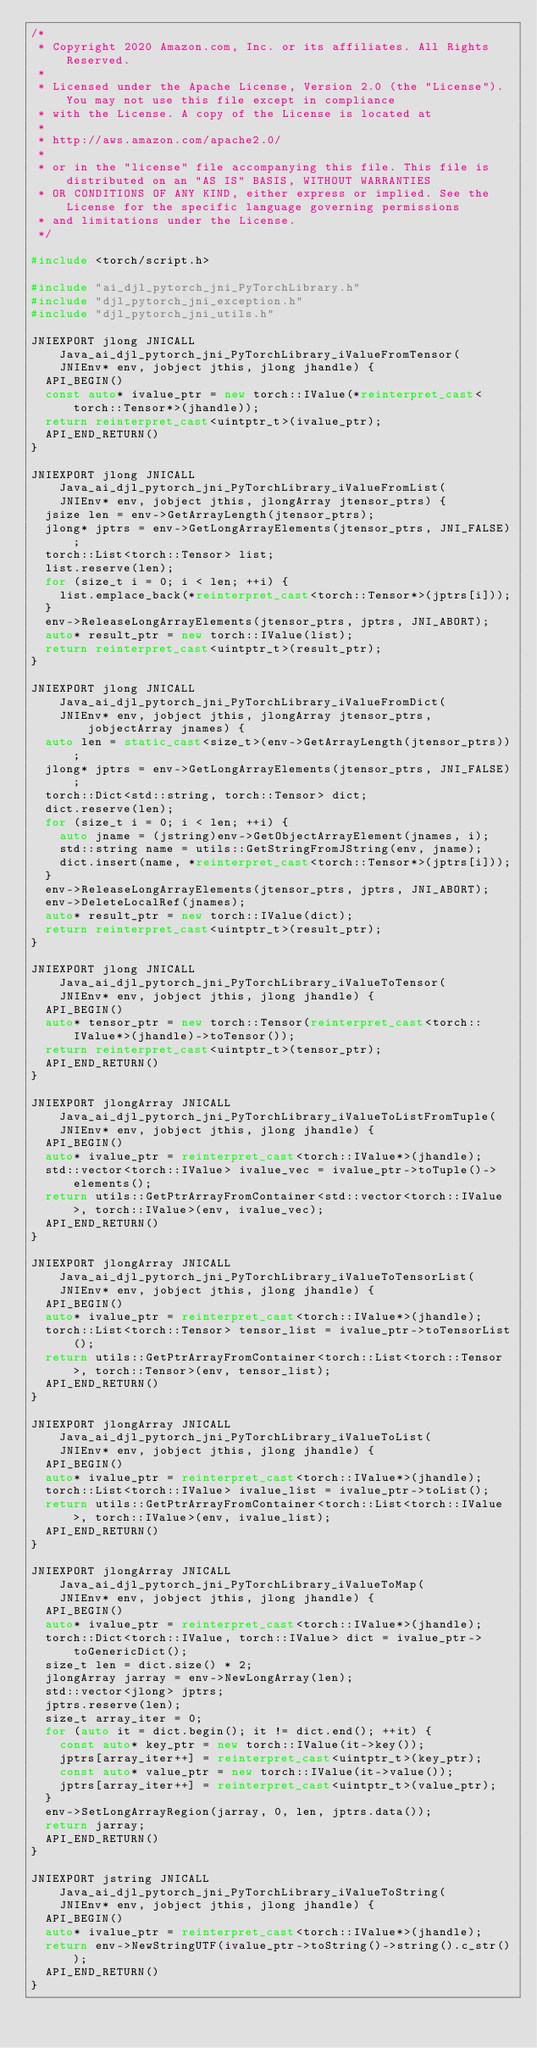<code> <loc_0><loc_0><loc_500><loc_500><_C++_>/*
 * Copyright 2020 Amazon.com, Inc. or its affiliates. All Rights Reserved.
 *
 * Licensed under the Apache License, Version 2.0 (the "License"). You may not use this file except in compliance
 * with the License. A copy of the License is located at
 *
 * http://aws.amazon.com/apache2.0/
 *
 * or in the "license" file accompanying this file. This file is distributed on an "AS IS" BASIS, WITHOUT WARRANTIES
 * OR CONDITIONS OF ANY KIND, either express or implied. See the License for the specific language governing permissions
 * and limitations under the License.
 */

#include <torch/script.h>

#include "ai_djl_pytorch_jni_PyTorchLibrary.h"
#include "djl_pytorch_jni_exception.h"
#include "djl_pytorch_jni_utils.h"

JNIEXPORT jlong JNICALL Java_ai_djl_pytorch_jni_PyTorchLibrary_iValueFromTensor(
    JNIEnv* env, jobject jthis, jlong jhandle) {
  API_BEGIN()
  const auto* ivalue_ptr = new torch::IValue(*reinterpret_cast<torch::Tensor*>(jhandle));
  return reinterpret_cast<uintptr_t>(ivalue_ptr);
  API_END_RETURN()
}

JNIEXPORT jlong JNICALL Java_ai_djl_pytorch_jni_PyTorchLibrary_iValueFromList(
    JNIEnv* env, jobject jthis, jlongArray jtensor_ptrs) {
  jsize len = env->GetArrayLength(jtensor_ptrs);
  jlong* jptrs = env->GetLongArrayElements(jtensor_ptrs, JNI_FALSE);
  torch::List<torch::Tensor> list;
  list.reserve(len);
  for (size_t i = 0; i < len; ++i) {
    list.emplace_back(*reinterpret_cast<torch::Tensor*>(jptrs[i]));
  }
  env->ReleaseLongArrayElements(jtensor_ptrs, jptrs, JNI_ABORT);
  auto* result_ptr = new torch::IValue(list);
  return reinterpret_cast<uintptr_t>(result_ptr);
}

JNIEXPORT jlong JNICALL Java_ai_djl_pytorch_jni_PyTorchLibrary_iValueFromDict(
    JNIEnv* env, jobject jthis, jlongArray jtensor_ptrs, jobjectArray jnames) {
  auto len = static_cast<size_t>(env->GetArrayLength(jtensor_ptrs));
  jlong* jptrs = env->GetLongArrayElements(jtensor_ptrs, JNI_FALSE);
  torch::Dict<std::string, torch::Tensor> dict;
  dict.reserve(len);
  for (size_t i = 0; i < len; ++i) {
    auto jname = (jstring)env->GetObjectArrayElement(jnames, i);
    std::string name = utils::GetStringFromJString(env, jname);
    dict.insert(name, *reinterpret_cast<torch::Tensor*>(jptrs[i]));
  }
  env->ReleaseLongArrayElements(jtensor_ptrs, jptrs, JNI_ABORT);
  env->DeleteLocalRef(jnames);
  auto* result_ptr = new torch::IValue(dict);
  return reinterpret_cast<uintptr_t>(result_ptr);
}

JNIEXPORT jlong JNICALL Java_ai_djl_pytorch_jni_PyTorchLibrary_iValueToTensor(
    JNIEnv* env, jobject jthis, jlong jhandle) {
  API_BEGIN()
  auto* tensor_ptr = new torch::Tensor(reinterpret_cast<torch::IValue*>(jhandle)->toTensor());
  return reinterpret_cast<uintptr_t>(tensor_ptr);
  API_END_RETURN()
}

JNIEXPORT jlongArray JNICALL Java_ai_djl_pytorch_jni_PyTorchLibrary_iValueToListFromTuple(
    JNIEnv* env, jobject jthis, jlong jhandle) {
  API_BEGIN()
  auto* ivalue_ptr = reinterpret_cast<torch::IValue*>(jhandle);
  std::vector<torch::IValue> ivalue_vec = ivalue_ptr->toTuple()->elements();
  return utils::GetPtrArrayFromContainer<std::vector<torch::IValue>, torch::IValue>(env, ivalue_vec);
  API_END_RETURN()
}

JNIEXPORT jlongArray JNICALL Java_ai_djl_pytorch_jni_PyTorchLibrary_iValueToTensorList(
    JNIEnv* env, jobject jthis, jlong jhandle) {
  API_BEGIN()
  auto* ivalue_ptr = reinterpret_cast<torch::IValue*>(jhandle);
  torch::List<torch::Tensor> tensor_list = ivalue_ptr->toTensorList();
  return utils::GetPtrArrayFromContainer<torch::List<torch::Tensor>, torch::Tensor>(env, tensor_list);
  API_END_RETURN()
}

JNIEXPORT jlongArray JNICALL Java_ai_djl_pytorch_jni_PyTorchLibrary_iValueToList(
    JNIEnv* env, jobject jthis, jlong jhandle) {
  API_BEGIN()
  auto* ivalue_ptr = reinterpret_cast<torch::IValue*>(jhandle);
  torch::List<torch::IValue> ivalue_list = ivalue_ptr->toList();
  return utils::GetPtrArrayFromContainer<torch::List<torch::IValue>, torch::IValue>(env, ivalue_list);
  API_END_RETURN()
}

JNIEXPORT jlongArray JNICALL Java_ai_djl_pytorch_jni_PyTorchLibrary_iValueToMap(
    JNIEnv* env, jobject jthis, jlong jhandle) {
  API_BEGIN()
  auto* ivalue_ptr = reinterpret_cast<torch::IValue*>(jhandle);
  torch::Dict<torch::IValue, torch::IValue> dict = ivalue_ptr->toGenericDict();
  size_t len = dict.size() * 2;
  jlongArray jarray = env->NewLongArray(len);
  std::vector<jlong> jptrs;
  jptrs.reserve(len);
  size_t array_iter = 0;
  for (auto it = dict.begin(); it != dict.end(); ++it) {
    const auto* key_ptr = new torch::IValue(it->key());
    jptrs[array_iter++] = reinterpret_cast<uintptr_t>(key_ptr);
    const auto* value_ptr = new torch::IValue(it->value());
    jptrs[array_iter++] = reinterpret_cast<uintptr_t>(value_ptr);
  }
  env->SetLongArrayRegion(jarray, 0, len, jptrs.data());
  return jarray;
  API_END_RETURN()
}

JNIEXPORT jstring JNICALL Java_ai_djl_pytorch_jni_PyTorchLibrary_iValueToString(
    JNIEnv* env, jobject jthis, jlong jhandle) {
  API_BEGIN()
  auto* ivalue_ptr = reinterpret_cast<torch::IValue*>(jhandle);
  return env->NewStringUTF(ivalue_ptr->toString()->string().c_str());
  API_END_RETURN()
}
</code> 